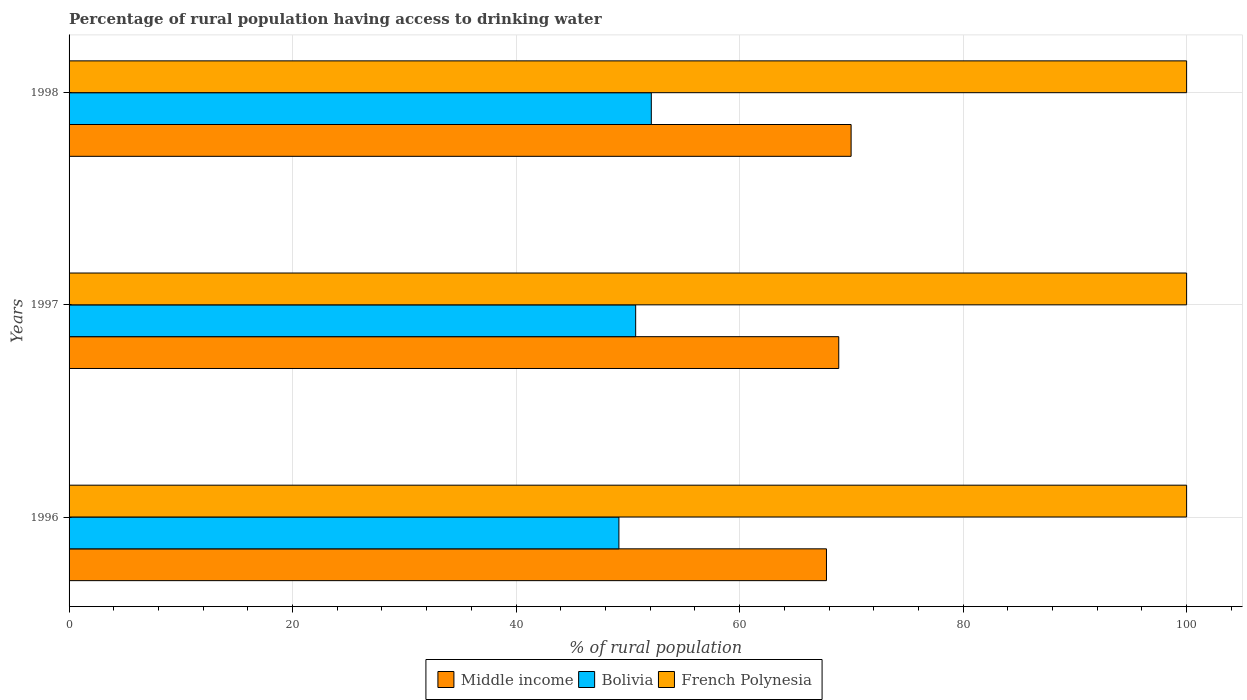In how many cases, is the number of bars for a given year not equal to the number of legend labels?
Provide a succinct answer. 0. What is the percentage of rural population having access to drinking water in French Polynesia in 1996?
Ensure brevity in your answer.  100. Across all years, what is the maximum percentage of rural population having access to drinking water in Bolivia?
Your answer should be compact. 52.1. Across all years, what is the minimum percentage of rural population having access to drinking water in French Polynesia?
Make the answer very short. 100. In which year was the percentage of rural population having access to drinking water in Middle income minimum?
Your answer should be very brief. 1996. What is the total percentage of rural population having access to drinking water in French Polynesia in the graph?
Keep it short and to the point. 300. What is the difference between the percentage of rural population having access to drinking water in French Polynesia in 1996 and the percentage of rural population having access to drinking water in Middle income in 1998?
Offer a terse response. 30.02. What is the average percentage of rural population having access to drinking water in Bolivia per year?
Your answer should be compact. 50.67. In the year 1996, what is the difference between the percentage of rural population having access to drinking water in French Polynesia and percentage of rural population having access to drinking water in Bolivia?
Offer a very short reply. 50.8. What is the ratio of the percentage of rural population having access to drinking water in Bolivia in 1996 to that in 1998?
Your answer should be compact. 0.94. Is the difference between the percentage of rural population having access to drinking water in French Polynesia in 1997 and 1998 greater than the difference between the percentage of rural population having access to drinking water in Bolivia in 1997 and 1998?
Your answer should be very brief. Yes. What is the difference between the highest and the second highest percentage of rural population having access to drinking water in Bolivia?
Offer a terse response. 1.4. What is the difference between the highest and the lowest percentage of rural population having access to drinking water in Middle income?
Provide a succinct answer. 2.2. In how many years, is the percentage of rural population having access to drinking water in French Polynesia greater than the average percentage of rural population having access to drinking water in French Polynesia taken over all years?
Your answer should be very brief. 0. Is the sum of the percentage of rural population having access to drinking water in French Polynesia in 1996 and 1998 greater than the maximum percentage of rural population having access to drinking water in Bolivia across all years?
Offer a terse response. Yes. What does the 2nd bar from the bottom in 1997 represents?
Provide a succinct answer. Bolivia. How many bars are there?
Your response must be concise. 9. Are all the bars in the graph horizontal?
Offer a very short reply. Yes. How many years are there in the graph?
Your response must be concise. 3. Are the values on the major ticks of X-axis written in scientific E-notation?
Your response must be concise. No. Does the graph contain any zero values?
Offer a terse response. No. Where does the legend appear in the graph?
Your response must be concise. Bottom center. How many legend labels are there?
Offer a terse response. 3. What is the title of the graph?
Make the answer very short. Percentage of rural population having access to drinking water. Does "High income" appear as one of the legend labels in the graph?
Your answer should be very brief. No. What is the label or title of the X-axis?
Your answer should be compact. % of rural population. What is the % of rural population in Middle income in 1996?
Ensure brevity in your answer.  67.77. What is the % of rural population in Bolivia in 1996?
Ensure brevity in your answer.  49.2. What is the % of rural population of French Polynesia in 1996?
Offer a terse response. 100. What is the % of rural population in Middle income in 1997?
Offer a terse response. 68.87. What is the % of rural population in Bolivia in 1997?
Make the answer very short. 50.7. What is the % of rural population of French Polynesia in 1997?
Your answer should be very brief. 100. What is the % of rural population in Middle income in 1998?
Give a very brief answer. 69.98. What is the % of rural population in Bolivia in 1998?
Provide a succinct answer. 52.1. Across all years, what is the maximum % of rural population in Middle income?
Provide a short and direct response. 69.98. Across all years, what is the maximum % of rural population in Bolivia?
Offer a terse response. 52.1. Across all years, what is the maximum % of rural population of French Polynesia?
Keep it short and to the point. 100. Across all years, what is the minimum % of rural population of Middle income?
Provide a succinct answer. 67.77. Across all years, what is the minimum % of rural population of Bolivia?
Provide a short and direct response. 49.2. What is the total % of rural population in Middle income in the graph?
Offer a terse response. 206.62. What is the total % of rural population of Bolivia in the graph?
Your answer should be compact. 152. What is the total % of rural population of French Polynesia in the graph?
Give a very brief answer. 300. What is the difference between the % of rural population in Middle income in 1996 and that in 1997?
Provide a short and direct response. -1.1. What is the difference between the % of rural population in Bolivia in 1996 and that in 1997?
Keep it short and to the point. -1.5. What is the difference between the % of rural population in French Polynesia in 1996 and that in 1997?
Give a very brief answer. 0. What is the difference between the % of rural population in Middle income in 1996 and that in 1998?
Ensure brevity in your answer.  -2.2. What is the difference between the % of rural population of Bolivia in 1996 and that in 1998?
Keep it short and to the point. -2.9. What is the difference between the % of rural population of Middle income in 1997 and that in 1998?
Your response must be concise. -1.11. What is the difference between the % of rural population in Bolivia in 1997 and that in 1998?
Make the answer very short. -1.4. What is the difference between the % of rural population of Middle income in 1996 and the % of rural population of Bolivia in 1997?
Give a very brief answer. 17.07. What is the difference between the % of rural population in Middle income in 1996 and the % of rural population in French Polynesia in 1997?
Ensure brevity in your answer.  -32.23. What is the difference between the % of rural population in Bolivia in 1996 and the % of rural population in French Polynesia in 1997?
Offer a very short reply. -50.8. What is the difference between the % of rural population of Middle income in 1996 and the % of rural population of Bolivia in 1998?
Ensure brevity in your answer.  15.67. What is the difference between the % of rural population of Middle income in 1996 and the % of rural population of French Polynesia in 1998?
Provide a succinct answer. -32.23. What is the difference between the % of rural population of Bolivia in 1996 and the % of rural population of French Polynesia in 1998?
Make the answer very short. -50.8. What is the difference between the % of rural population of Middle income in 1997 and the % of rural population of Bolivia in 1998?
Your answer should be very brief. 16.77. What is the difference between the % of rural population of Middle income in 1997 and the % of rural population of French Polynesia in 1998?
Give a very brief answer. -31.13. What is the difference between the % of rural population of Bolivia in 1997 and the % of rural population of French Polynesia in 1998?
Your answer should be very brief. -49.3. What is the average % of rural population of Middle income per year?
Ensure brevity in your answer.  68.87. What is the average % of rural population of Bolivia per year?
Your answer should be compact. 50.67. In the year 1996, what is the difference between the % of rural population in Middle income and % of rural population in Bolivia?
Provide a short and direct response. 18.57. In the year 1996, what is the difference between the % of rural population in Middle income and % of rural population in French Polynesia?
Ensure brevity in your answer.  -32.23. In the year 1996, what is the difference between the % of rural population in Bolivia and % of rural population in French Polynesia?
Your response must be concise. -50.8. In the year 1997, what is the difference between the % of rural population in Middle income and % of rural population in Bolivia?
Offer a terse response. 18.17. In the year 1997, what is the difference between the % of rural population of Middle income and % of rural population of French Polynesia?
Your answer should be very brief. -31.13. In the year 1997, what is the difference between the % of rural population of Bolivia and % of rural population of French Polynesia?
Offer a very short reply. -49.3. In the year 1998, what is the difference between the % of rural population of Middle income and % of rural population of Bolivia?
Provide a short and direct response. 17.88. In the year 1998, what is the difference between the % of rural population of Middle income and % of rural population of French Polynesia?
Provide a succinct answer. -30.02. In the year 1998, what is the difference between the % of rural population in Bolivia and % of rural population in French Polynesia?
Provide a short and direct response. -47.9. What is the ratio of the % of rural population of Middle income in 1996 to that in 1997?
Make the answer very short. 0.98. What is the ratio of the % of rural population in Bolivia in 1996 to that in 1997?
Offer a terse response. 0.97. What is the ratio of the % of rural population in French Polynesia in 1996 to that in 1997?
Your response must be concise. 1. What is the ratio of the % of rural population of Middle income in 1996 to that in 1998?
Give a very brief answer. 0.97. What is the ratio of the % of rural population of Bolivia in 1996 to that in 1998?
Provide a succinct answer. 0.94. What is the ratio of the % of rural population in French Polynesia in 1996 to that in 1998?
Keep it short and to the point. 1. What is the ratio of the % of rural population of Middle income in 1997 to that in 1998?
Ensure brevity in your answer.  0.98. What is the ratio of the % of rural population in Bolivia in 1997 to that in 1998?
Offer a terse response. 0.97. What is the difference between the highest and the second highest % of rural population of Middle income?
Your answer should be very brief. 1.11. What is the difference between the highest and the lowest % of rural population of Middle income?
Offer a terse response. 2.2. What is the difference between the highest and the lowest % of rural population of Bolivia?
Your answer should be very brief. 2.9. What is the difference between the highest and the lowest % of rural population of French Polynesia?
Keep it short and to the point. 0. 